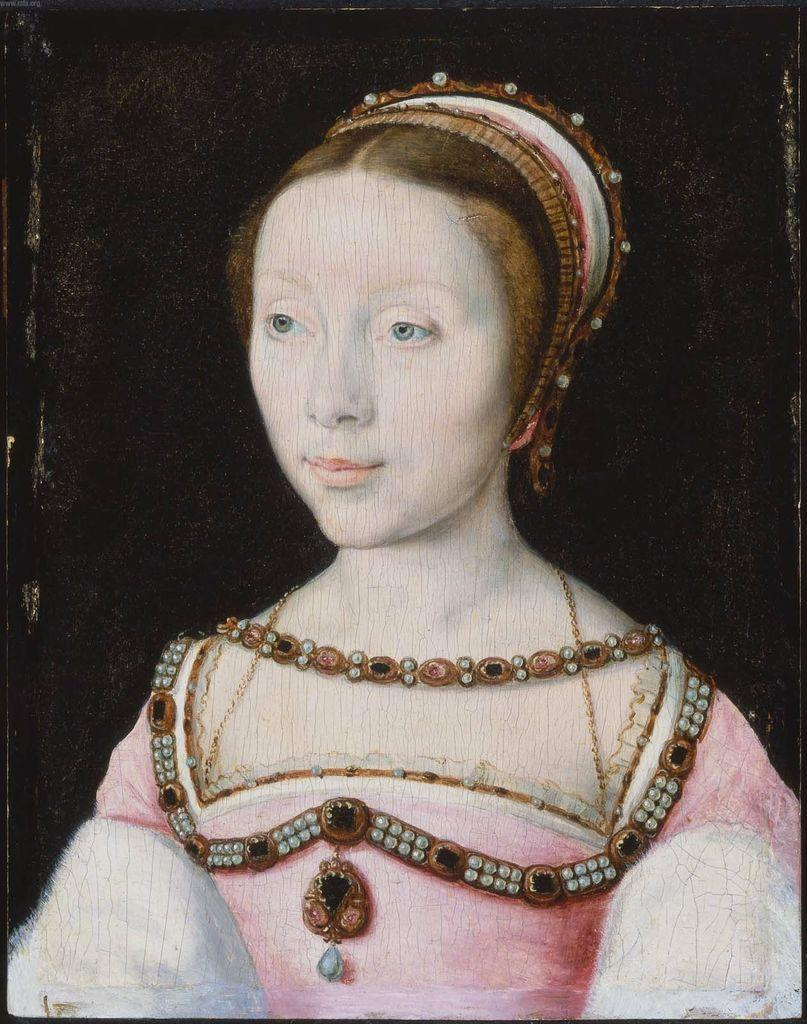What is the main subject of the image? The image contains a painting. What is depicted in the painting? The painting depicts a woman. What is the woman wearing in the painting? The woman is wearing a pink dress. What type of quill is the woman holding in the painting? There is no quill present in the painting; the woman is depicted wearing a pink dress. 